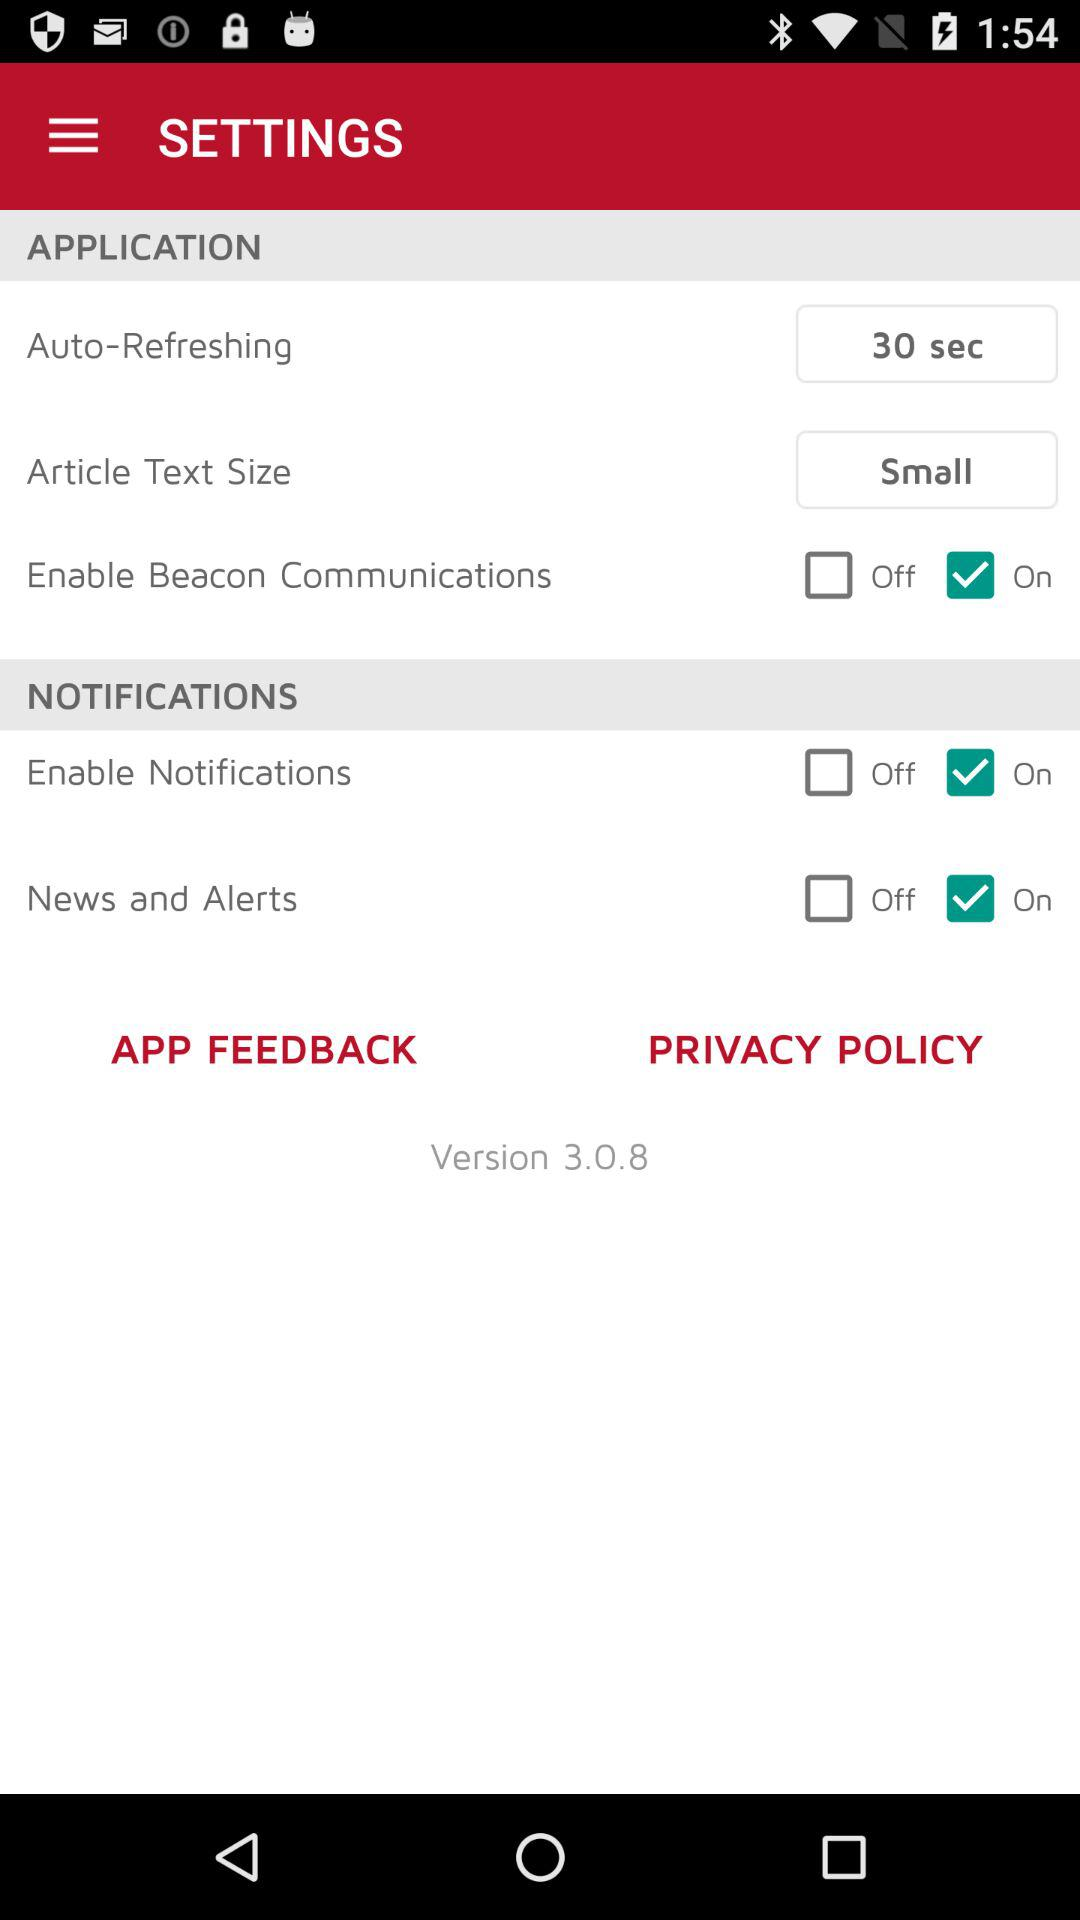What is the "Auto-Refreshing" time? The "Auto-Refreshing" time is 30 seconds. 